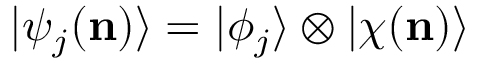Convert formula to latex. <formula><loc_0><loc_0><loc_500><loc_500>| \psi _ { j } ( n ) \rangle = | \phi _ { j } \rangle \otimes | \chi ( n ) \rangle</formula> 